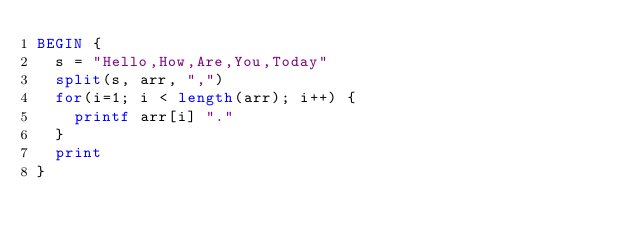<code> <loc_0><loc_0><loc_500><loc_500><_Awk_>BEGIN {
  s = "Hello,How,Are,You,Today"
  split(s, arr, ",")
  for(i=1; i < length(arr); i++) {
    printf arr[i] "."
  }
  print
}
</code> 